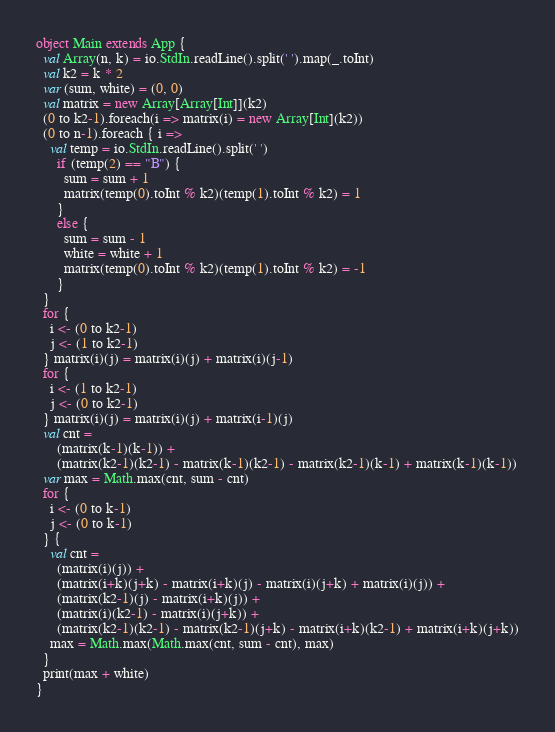Convert code to text. <code><loc_0><loc_0><loc_500><loc_500><_Scala_>object Main extends App {
  val Array(n, k) = io.StdIn.readLine().split(' ').map(_.toInt)
  val k2 = k * 2
  var (sum, white) = (0, 0)
  val matrix = new Array[Array[Int]](k2)
  (0 to k2-1).foreach(i => matrix(i) = new Array[Int](k2))
  (0 to n-1).foreach { i =>
    val temp = io.StdIn.readLine().split(' ')
      if (temp(2) == "B") {
        sum = sum + 1
        matrix(temp(0).toInt % k2)(temp(1).toInt % k2) = 1
      }
      else {
        sum = sum - 1
        white = white + 1
        matrix(temp(0).toInt % k2)(temp(1).toInt % k2) = -1
      }
  }
  for {
    i <- (0 to k2-1)
    j <- (1 to k2-1)
  } matrix(i)(j) = matrix(i)(j) + matrix(i)(j-1)
  for {
    i <- (1 to k2-1)
    j <- (0 to k2-1)
  } matrix(i)(j) = matrix(i)(j) + matrix(i-1)(j)
  val cnt =
      (matrix(k-1)(k-1)) +
      (matrix(k2-1)(k2-1) - matrix(k-1)(k2-1) - matrix(k2-1)(k-1) + matrix(k-1)(k-1))
  var max = Math.max(cnt, sum - cnt)
  for { 
    i <- (0 to k-1)
    j <- (0 to k-1)
  } {
    val cnt = 
      (matrix(i)(j)) +
      (matrix(i+k)(j+k) - matrix(i+k)(j) - matrix(i)(j+k) + matrix(i)(j)) +
      (matrix(k2-1)(j) - matrix(i+k)(j)) +
      (matrix(i)(k2-1) - matrix(i)(j+k)) +
      (matrix(k2-1)(k2-1) - matrix(k2-1)(j+k) - matrix(i+k)(k2-1) + matrix(i+k)(j+k))
    max = Math.max(Math.max(cnt, sum - cnt), max)
  }
  print(max + white)
}
</code> 